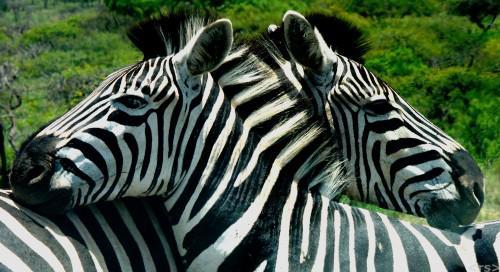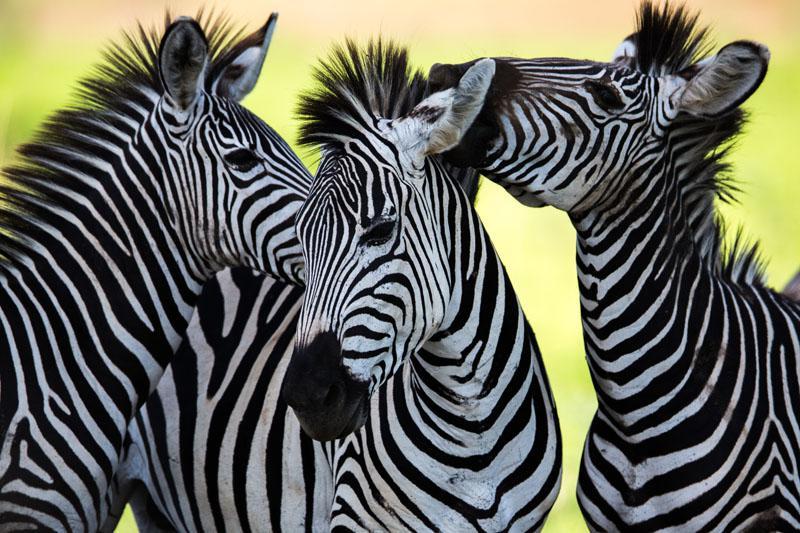The first image is the image on the left, the second image is the image on the right. Examine the images to the left and right. Is the description "The right image contains no more than two zebras." accurate? Answer yes or no. No. The first image is the image on the left, the second image is the image on the right. Analyze the images presented: Is the assertion "Each image contains multiple zebras, and one image shows exactly two zebras posed with one's head over the other's back." valid? Answer yes or no. Yes. 